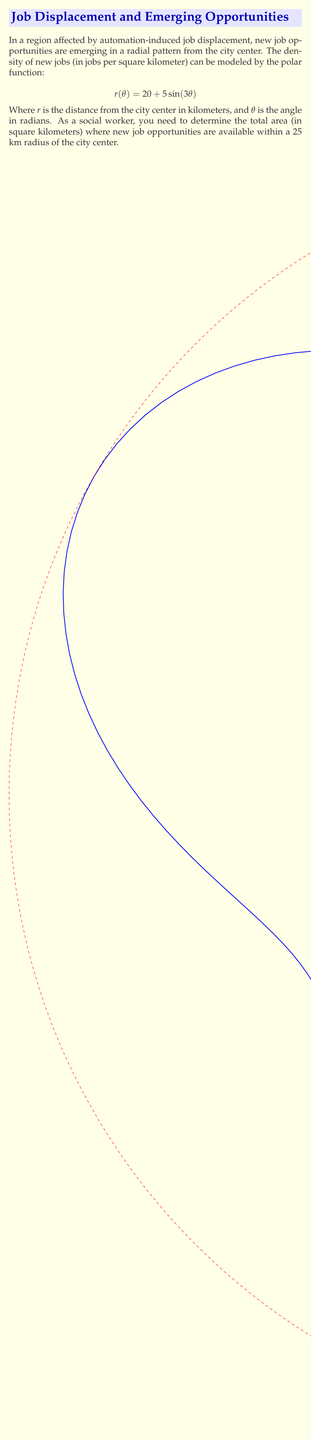Give your solution to this math problem. To solve this problem, we need to follow these steps:

1) The area enclosed by a polar curve is given by the formula:

   $$A = \frac{1}{2} \int_{0}^{2\pi} [r(\theta)]^2 d\theta$$

2) In this case, $r(\theta) = 20 + 5\sin(3\theta)$. We need to square this function:

   $$[r(\theta)]^2 = (20 + 5\sin(3\theta))^2 = 400 + 200\sin(3\theta) + 25\sin^2(3\theta)$$

3) Now, we set up the integral:

   $$A = \frac{1}{2} \int_{0}^{2\pi} (400 + 200\sin(3\theta) + 25\sin^2(3\theta)) d\theta$$

4) Let's integrate each term separately:
   
   a) $\int_{0}^{2\pi} 400 d\theta = 400\theta \big|_{0}^{2\pi} = 800\pi$
   
   b) $\int_{0}^{2\pi} 200\sin(3\theta) d\theta = -\frac{200}{3}\cos(3\theta) \big|_{0}^{2\pi} = 0$
   
   c) $\int_{0}^{2\pi} 25\sin^2(3\theta) d\theta = 25 \cdot \frac{\pi}{2} = \frac{25\pi}{2}$

5) Sum these results and multiply by $\frac{1}{2}$:

   $$A = \frac{1}{2} (800\pi + 0 + \frac{25\pi}{2}) = 400\pi + \frac{25\pi}{4} = \frac{1625\pi}{4} \approx 1273.24 \text{ km}^2$$

6) However, we need to limit this to within a 25 km radius. The area of a circle with radius 25 km is:

   $$A_{circle} = \pi r^2 = \pi(25)^2 = 625\pi \approx 1963.50 \text{ km}^2$$

7) Since the area within the job density curve is smaller than the 25 km radius circle, the entire area calculated in step 5 is the answer.
Answer: $\frac{1625\pi}{4} \approx 1273.24 \text{ km}^2$ 